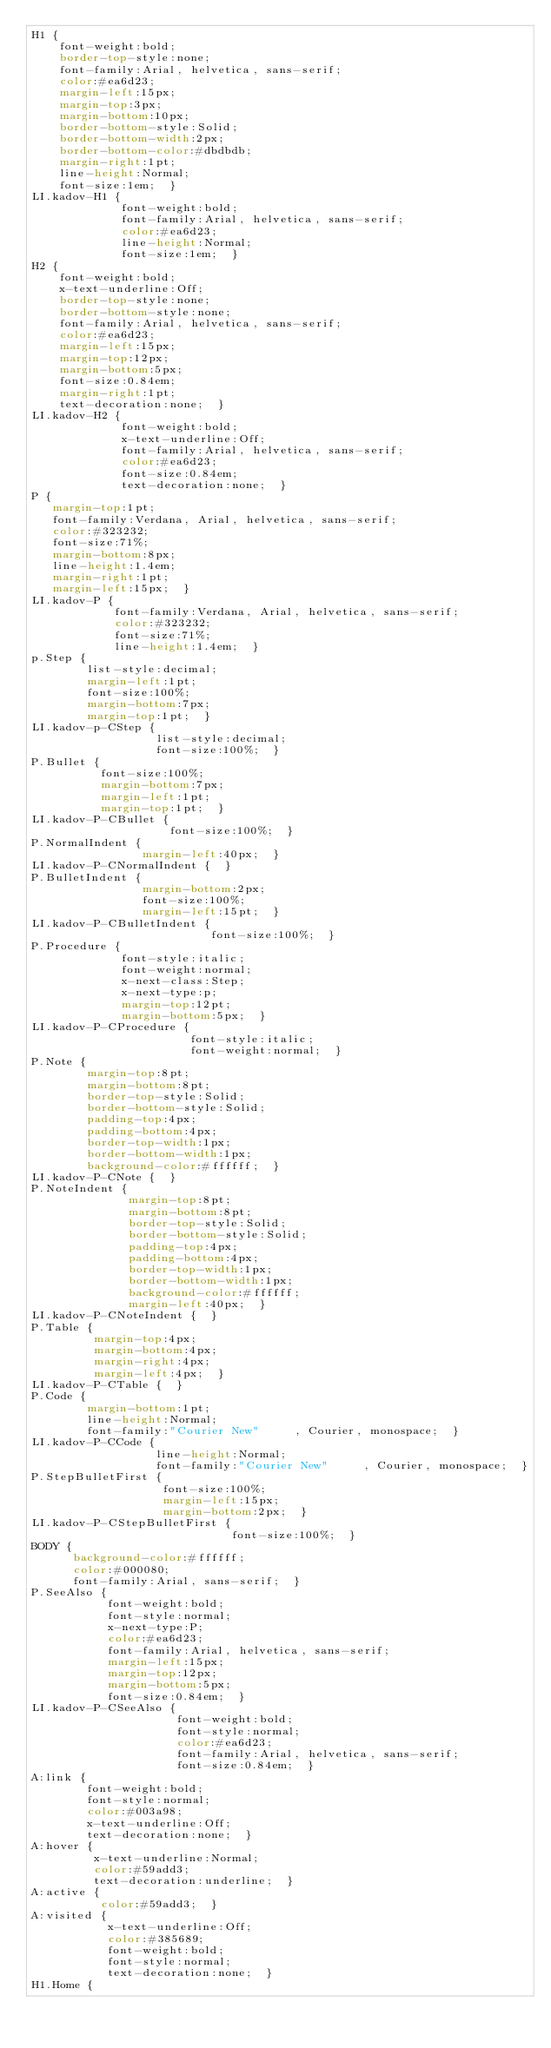<code> <loc_0><loc_0><loc_500><loc_500><_CSS_>H1 { 
    font-weight:bold; 
    border-top-style:none; 
    font-family:Arial, helvetica, sans-serif; 
    color:#ea6d23; 
    margin-left:15px; 
    margin-top:3px; 
    margin-bottom:10px; 
    border-bottom-style:Solid; 
    border-bottom-width:2px; 
    border-bottom-color:#dbdbdb; 
    margin-right:1pt; 
    line-height:Normal; 
    font-size:1em;  }
LI.kadov-H1 { 
             font-weight:bold; 
             font-family:Arial, helvetica, sans-serif; 
             color:#ea6d23; 
             line-height:Normal; 
             font-size:1em;  }
H2 { 
    font-weight:bold; 
    x-text-underline:Off; 
    border-top-style:none; 
    border-bottom-style:none; 
    font-family:Arial, helvetica, sans-serif; 
    color:#ea6d23; 
    margin-left:15px; 
    margin-top:12px; 
    margin-bottom:5px; 
    font-size:0.84em; 
    margin-right:1pt; 
    text-decoration:none;  }
LI.kadov-H2 { 
             font-weight:bold; 
             x-text-underline:Off; 
             font-family:Arial, helvetica, sans-serif; 
             color:#ea6d23; 
             font-size:0.84em; 
             text-decoration:none;  }
P { 
   margin-top:1pt; 
   font-family:Verdana, Arial, helvetica, sans-serif; 
   color:#323232; 
   font-size:71%; 
   margin-bottom:8px; 
   line-height:1.4em; 
   margin-right:1pt; 
   margin-left:15px;  }
LI.kadov-P { 
            font-family:Verdana, Arial, helvetica, sans-serif; 
            color:#323232; 
            font-size:71%; 
            line-height:1.4em;  }
p.Step { 
        list-style:decimal; 
        margin-left:1pt; 
        font-size:100%; 
        margin-bottom:7px; 
        margin-top:1pt;  }
LI.kadov-p-CStep { 
                  list-style:decimal; 
                  font-size:100%;  }
P.Bullet { 
          font-size:100%; 
          margin-bottom:7px; 
          margin-left:1pt; 
          margin-top:1pt;  }
LI.kadov-P-CBullet { 
                    font-size:100%;  }
P.NormalIndent { 
                margin-left:40px;  }
LI.kadov-P-CNormalIndent {  }
P.BulletIndent { 
                margin-bottom:2px; 
                font-size:100%; 
                margin-left:15pt;  }
LI.kadov-P-CBulletIndent { 
                          font-size:100%;  }
P.Procedure { 
             font-style:italic; 
             font-weight:normal; 
             x-next-class:Step; 
             x-next-type:p; 
             margin-top:12pt; 
             margin-bottom:5px;  }
LI.kadov-P-CProcedure { 
                       font-style:italic; 
                       font-weight:normal;  }
P.Note { 
        margin-top:8pt; 
        margin-bottom:8pt; 
        border-top-style:Solid; 
        border-bottom-style:Solid; 
        padding-top:4px; 
        padding-bottom:4px; 
        border-top-width:1px; 
        border-bottom-width:1px; 
        background-color:#ffffff;  }
LI.kadov-P-CNote {  }
P.NoteIndent { 
              margin-top:8pt; 
              margin-bottom:8pt; 
              border-top-style:Solid; 
              border-bottom-style:Solid; 
              padding-top:4px; 
              padding-bottom:4px; 
              border-top-width:1px; 
              border-bottom-width:1px; 
              background-color:#ffffff; 
              margin-left:40px;  }
LI.kadov-P-CNoteIndent {  }
P.Table { 
         margin-top:4px; 
         margin-bottom:4px; 
         margin-right:4px; 
         margin-left:4px;  }
LI.kadov-P-CTable {  }
P.Code { 
        margin-bottom:1pt; 
        line-height:Normal; 
        font-family:"Courier New"     , Courier, monospace;  }
LI.kadov-P-CCode { 
                  line-height:Normal; 
                  font-family:"Courier New"     , Courier, monospace;  }
P.StepBulletFirst { 
                   font-size:100%; 
                   margin-left:15px; 
                   margin-bottom:2px;  }
LI.kadov-P-CStepBulletFirst { 
                             font-size:100%;  }
BODY { 
      background-color:#ffffff; 
      color:#000080; 
      font-family:Arial, sans-serif;  }
P.SeeAlso { 
           font-weight:bold; 
           font-style:normal; 
           x-next-type:P; 
           color:#ea6d23; 
           font-family:Arial, helvetica, sans-serif; 
           margin-left:15px; 
           margin-top:12px; 
           margin-bottom:5px; 
           font-size:0.84em;  }
LI.kadov-P-CSeeAlso { 
                     font-weight:bold; 
                     font-style:normal; 
                     color:#ea6d23; 
                     font-family:Arial, helvetica, sans-serif; 
                     font-size:0.84em;  }
A:link { 
        font-weight:bold; 
        font-style:normal; 
        color:#003a98; 
        x-text-underline:Off; 
        text-decoration:none;  }
A:hover { 
         x-text-underline:Normal; 
         color:#59add3; 
         text-decoration:underline;  }
A:active { 
          color:#59add3;  }
A:visited { 
           x-text-underline:Off; 
           color:#385689; 
           font-weight:bold; 
           font-style:normal; 
           text-decoration:none;  }
H1.Home { </code> 